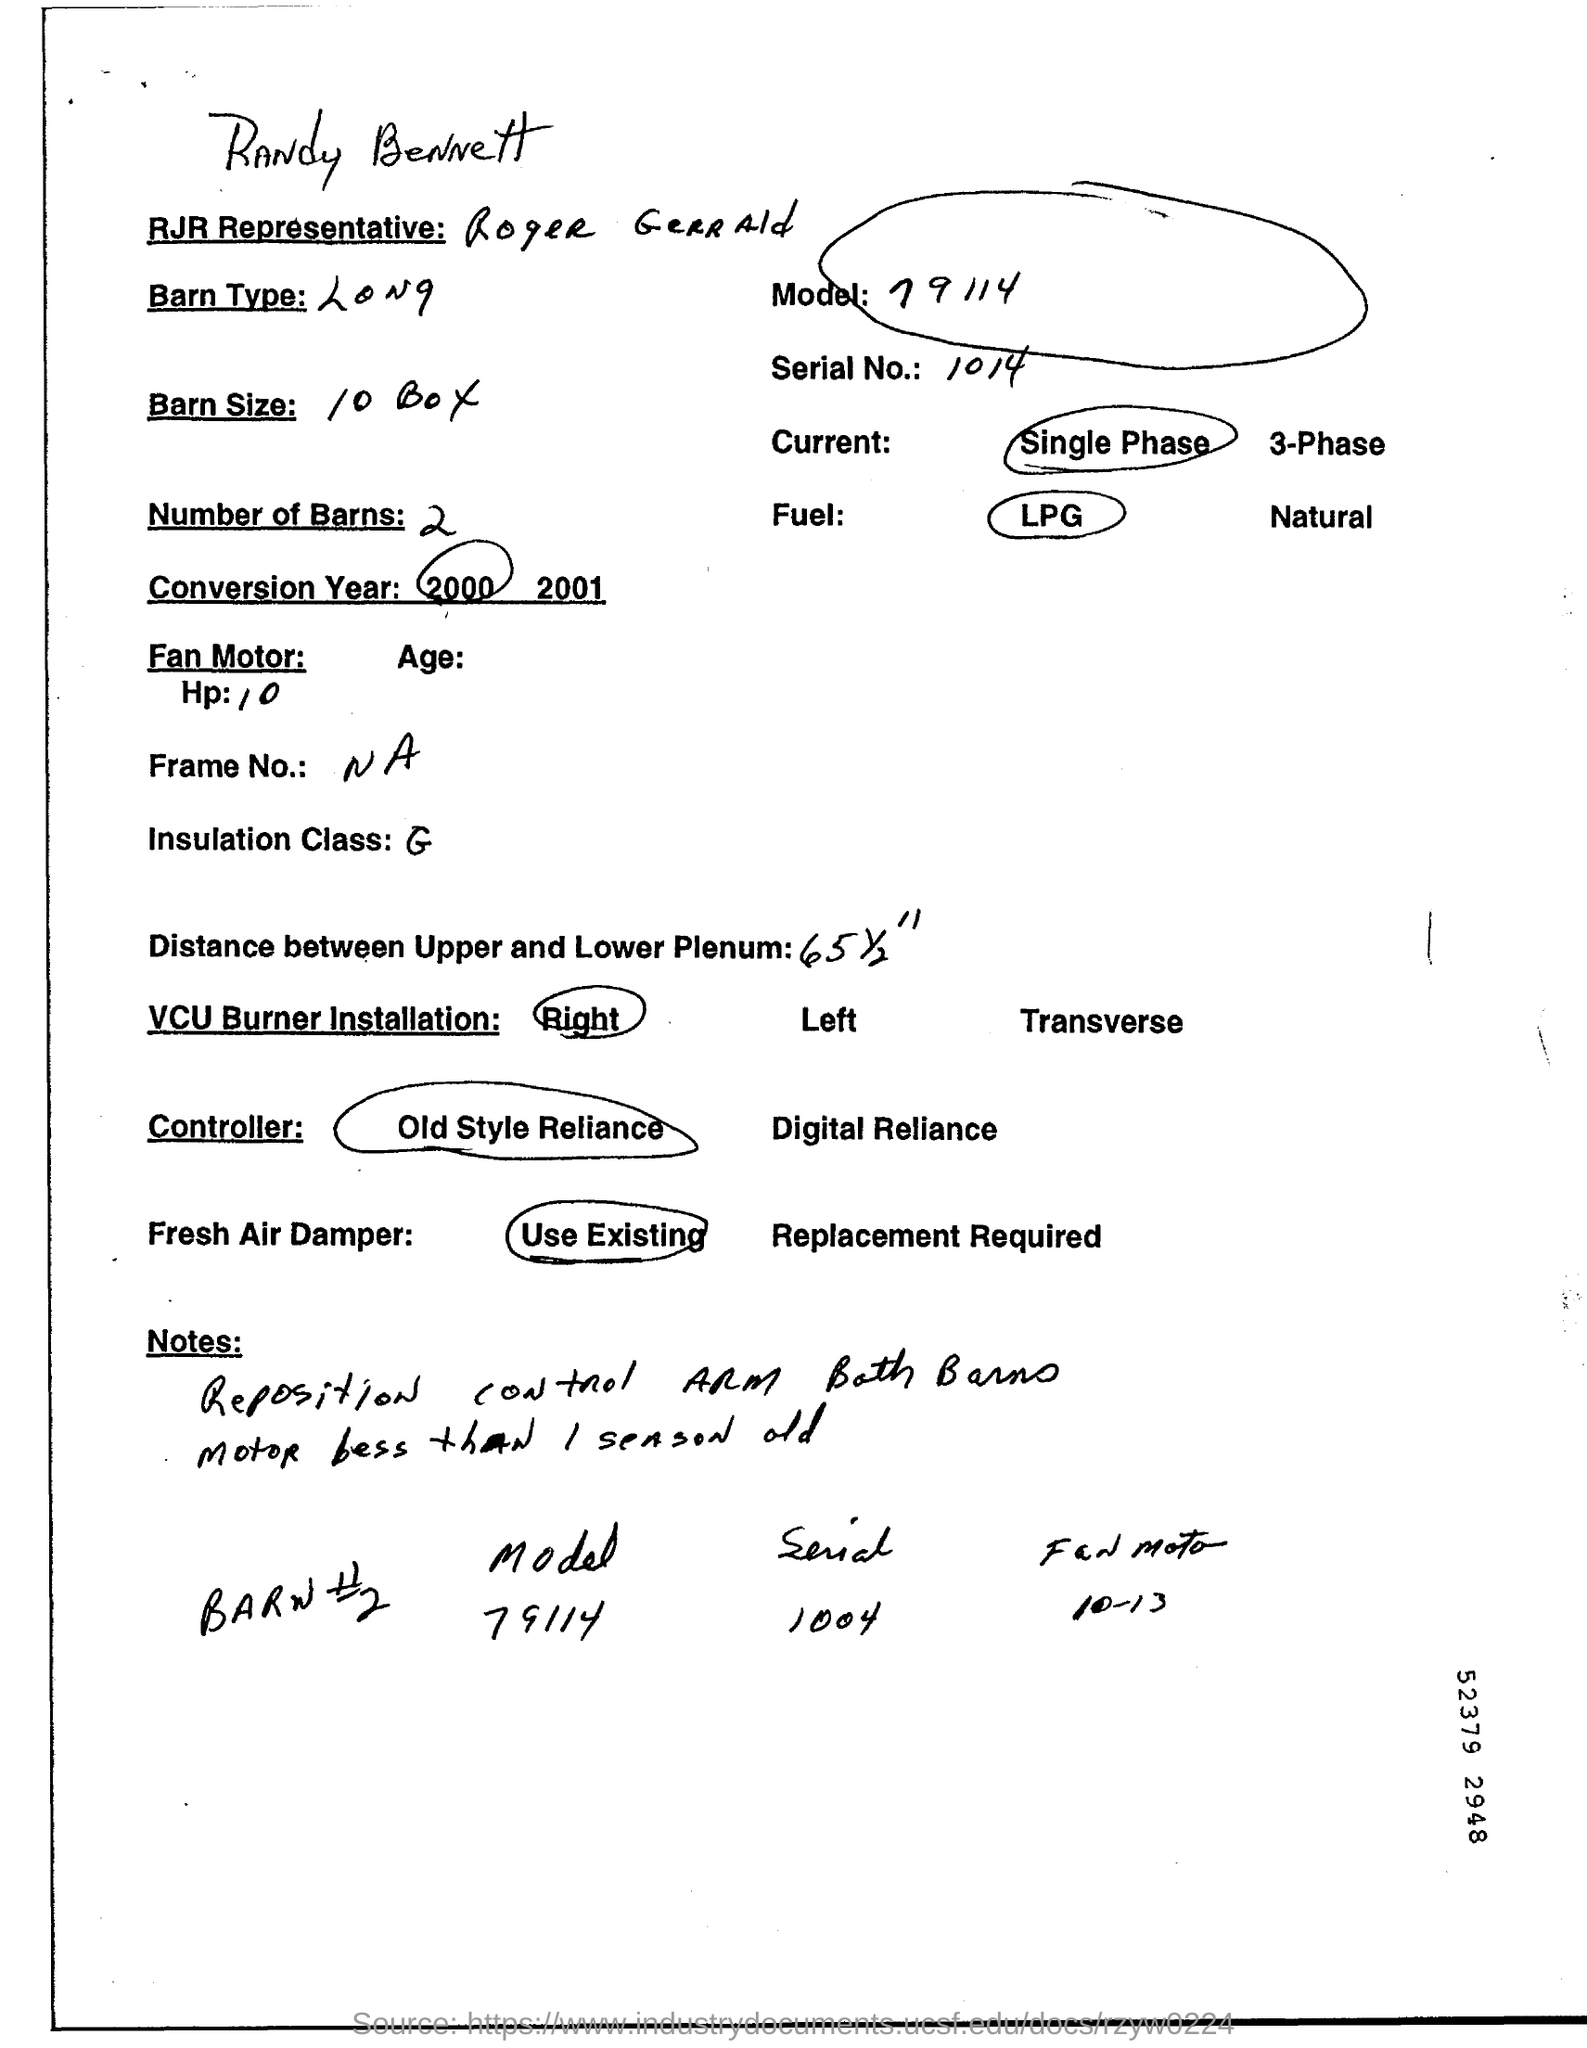Identify some key points in this picture. The type of fuel that is circled is Liquid Petroleum Gas (LPG). There are two barns mentioned. The model number is 79114," stated the customer to the representative. The year that is circled is 2000. 